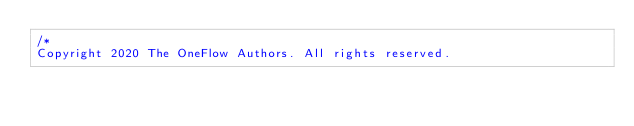<code> <loc_0><loc_0><loc_500><loc_500><_Cuda_>/*
Copyright 2020 The OneFlow Authors. All rights reserved.
</code> 